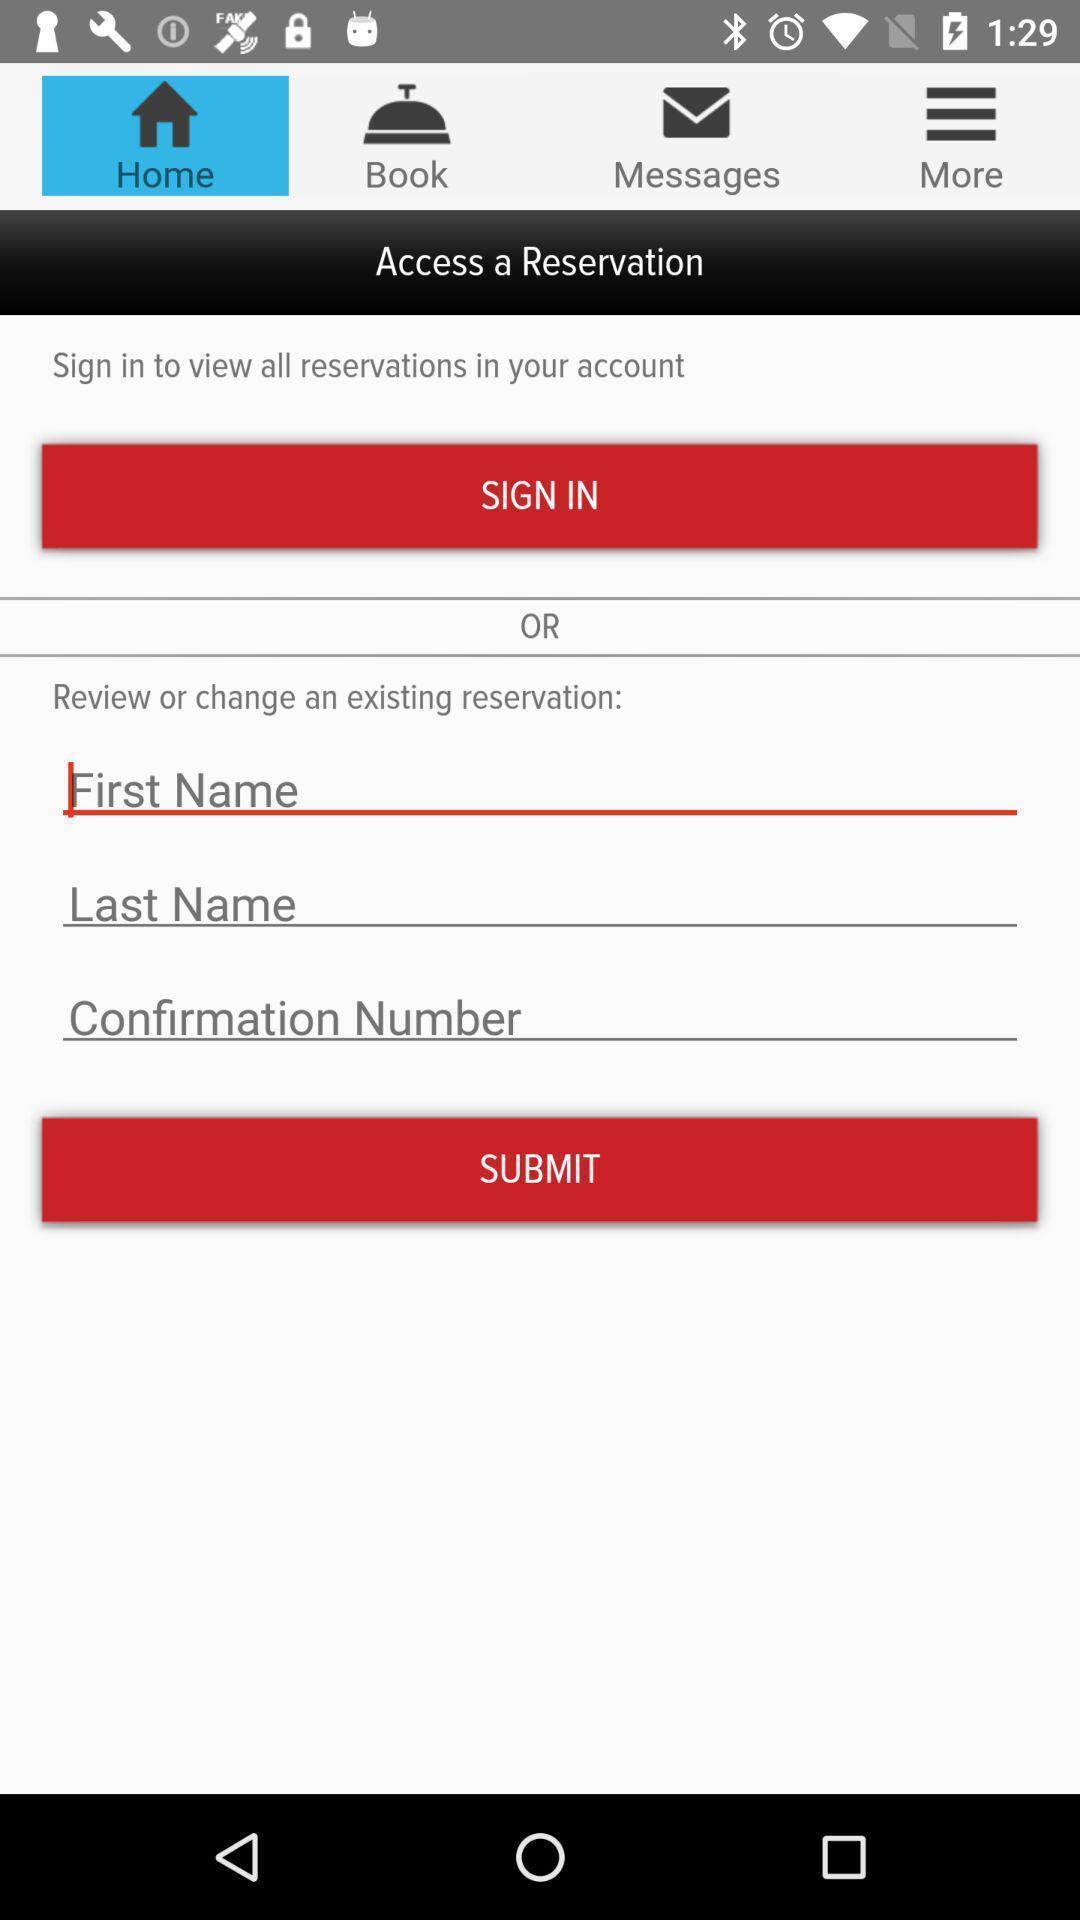Tell me about the visual elements in this screen capture. Sign up page in a reservation application. 